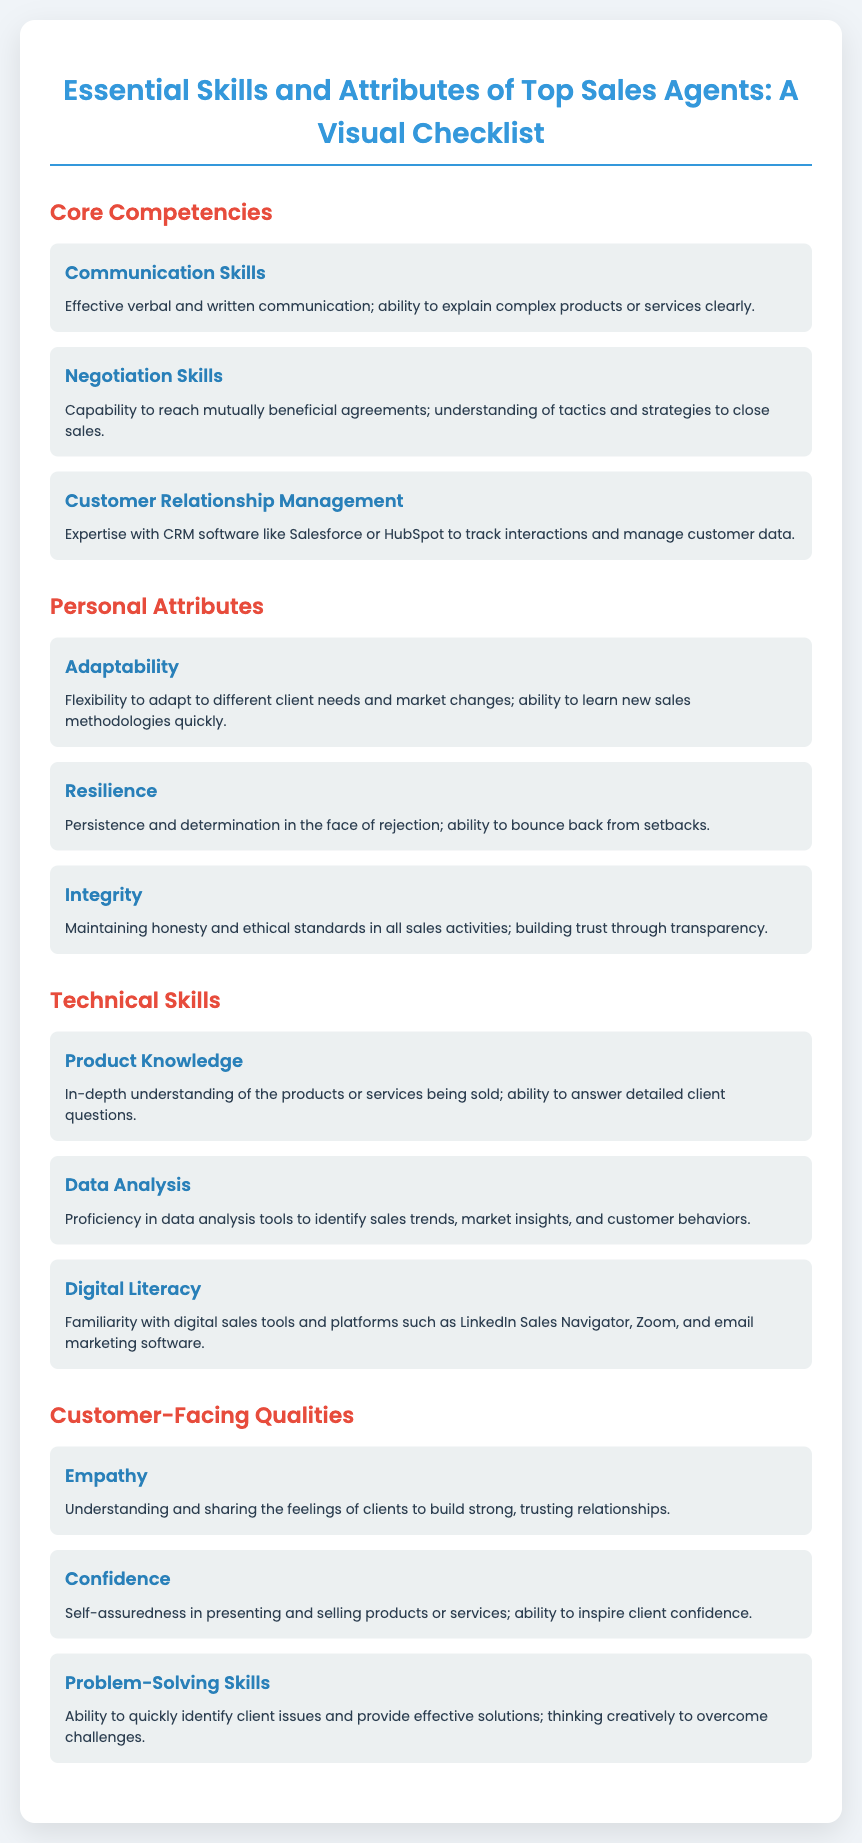What are the core competencies listed? The core competencies are the skills or abilities essential for top sales agents, as outlined in the section labeled "Core Competencies."
Answer: Communication Skills, Negotiation Skills, Customer Relationship Management How many personal attributes are described? The document details the personal attributes under the section "Personal Attributes," indicating a count of each listed trait.
Answer: Three What skill is highlighted under technical skills that involves understanding products? The skill refers to comprehensive knowledge about what is being sold, specified in the "Technical Skills" section.
Answer: Product Knowledge Which personal attribute focuses on flexibility? This attribute emphasizes the capability of being adaptable in various circumstances, as mentioned in the section on personal attributes.
Answer: Adaptability What quality is essential for building trust with clients? This quality is a fundamental personal attribute that fosters honesty and integrity with clients, as outlined in the personal attributes section.
Answer: Integrity Which section contains skills needed for digital platforms? This section provides insight into the necessary technological proficiencies for sales agents, detailed under a specific heading focused on skills.
Answer: Technical Skills What attribute helps in sharing feelings with clients? This personal quality is crucial for developing rapport and connection with clients, specifically noted in the customer-facing qualities.
Answer: Empathy How does a top sales agent recover from setbacks? The ability of sales agents to persist despite challenges and rejection is described in the personal attributes section, thereby characterizing resilient agents.
Answer: Resilience 